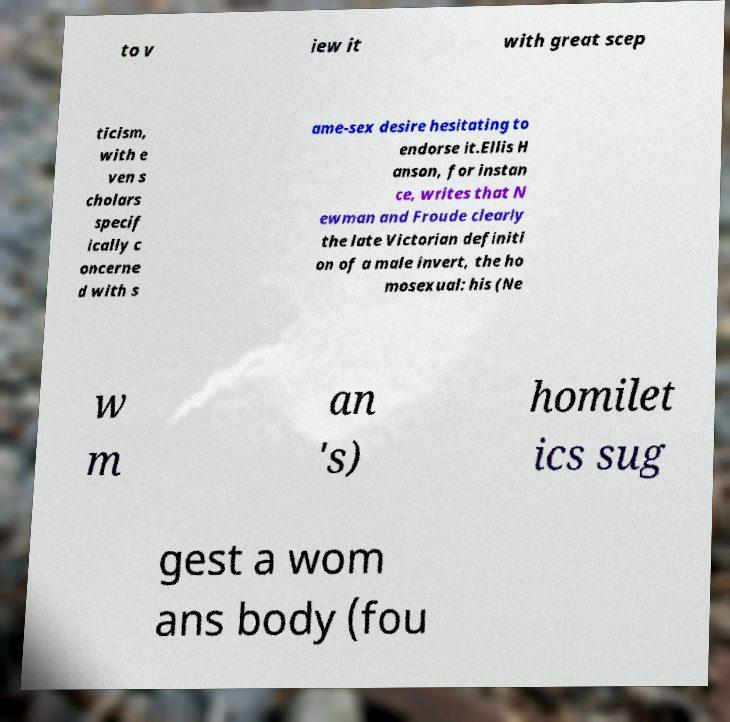Please identify and transcribe the text found in this image. to v iew it with great scep ticism, with e ven s cholars specif ically c oncerne d with s ame-sex desire hesitating to endorse it.Ellis H anson, for instan ce, writes that N ewman and Froude clearly the late Victorian definiti on of a male invert, the ho mosexual: his (Ne w m an 's) homilet ics sug gest a wom ans body (fou 